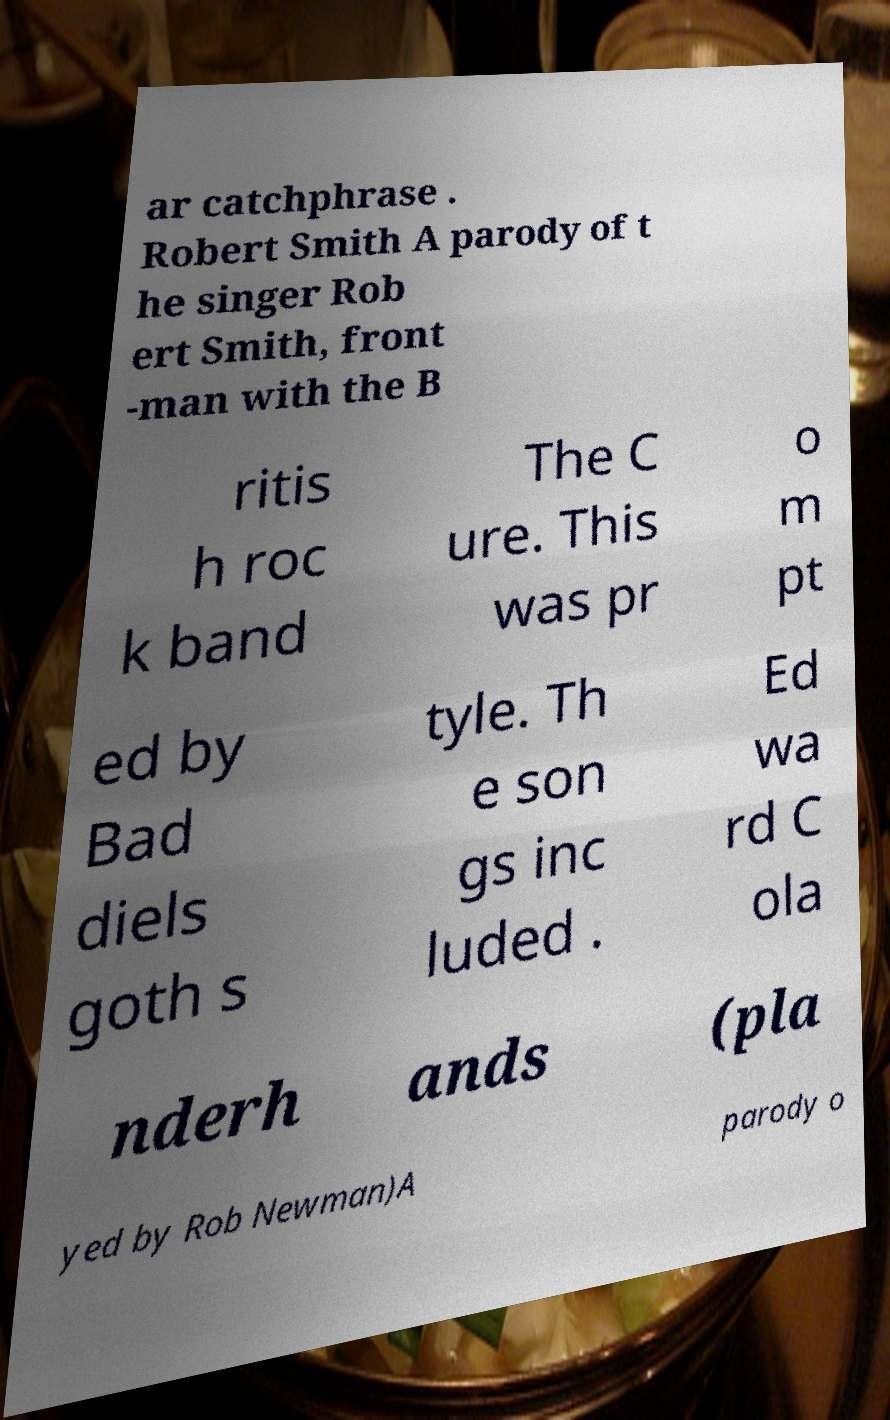Can you read and provide the text displayed in the image?This photo seems to have some interesting text. Can you extract and type it out for me? ar catchphrase . Robert Smith A parody of t he singer Rob ert Smith, front -man with the B ritis h roc k band The C ure. This was pr o m pt ed by Bad diels goth s tyle. Th e son gs inc luded . Ed wa rd C ola nderh ands (pla yed by Rob Newman)A parody o 